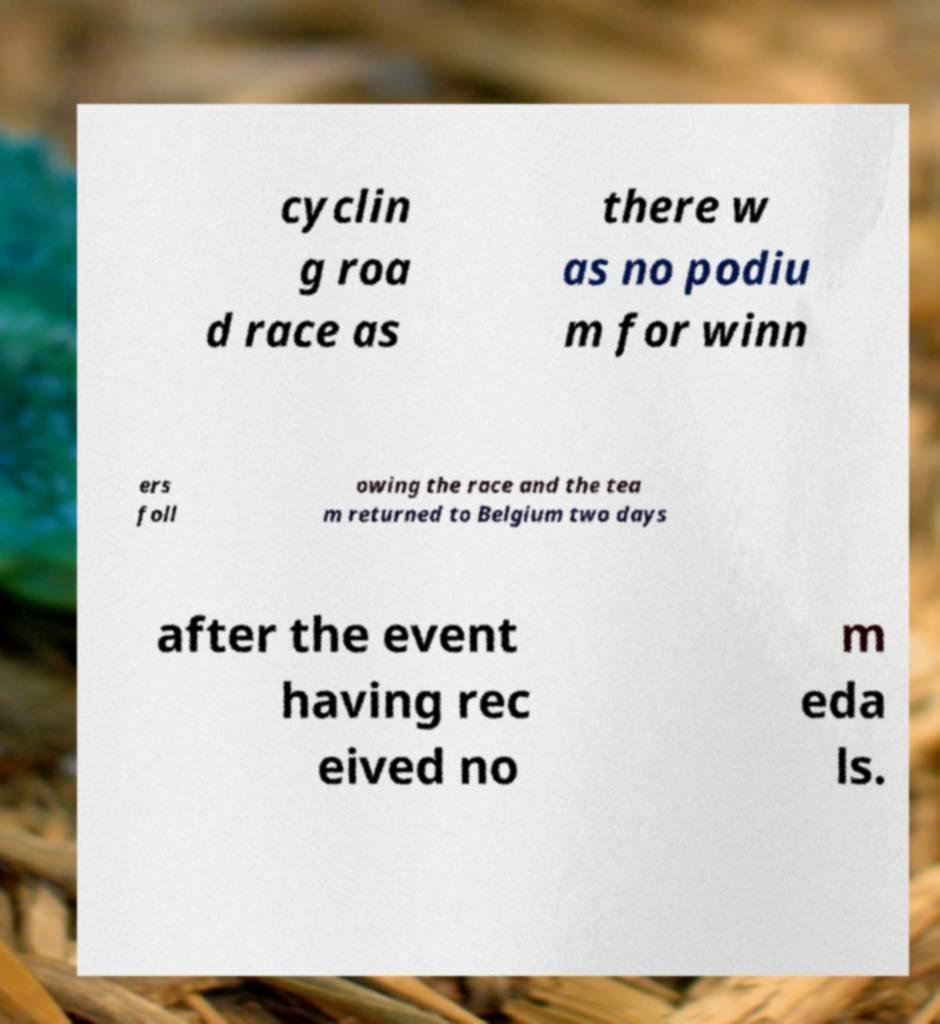Can you accurately transcribe the text from the provided image for me? cyclin g roa d race as there w as no podiu m for winn ers foll owing the race and the tea m returned to Belgium two days after the event having rec eived no m eda ls. 